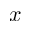Convert formula to latex. <formula><loc_0><loc_0><loc_500><loc_500>x</formula> 